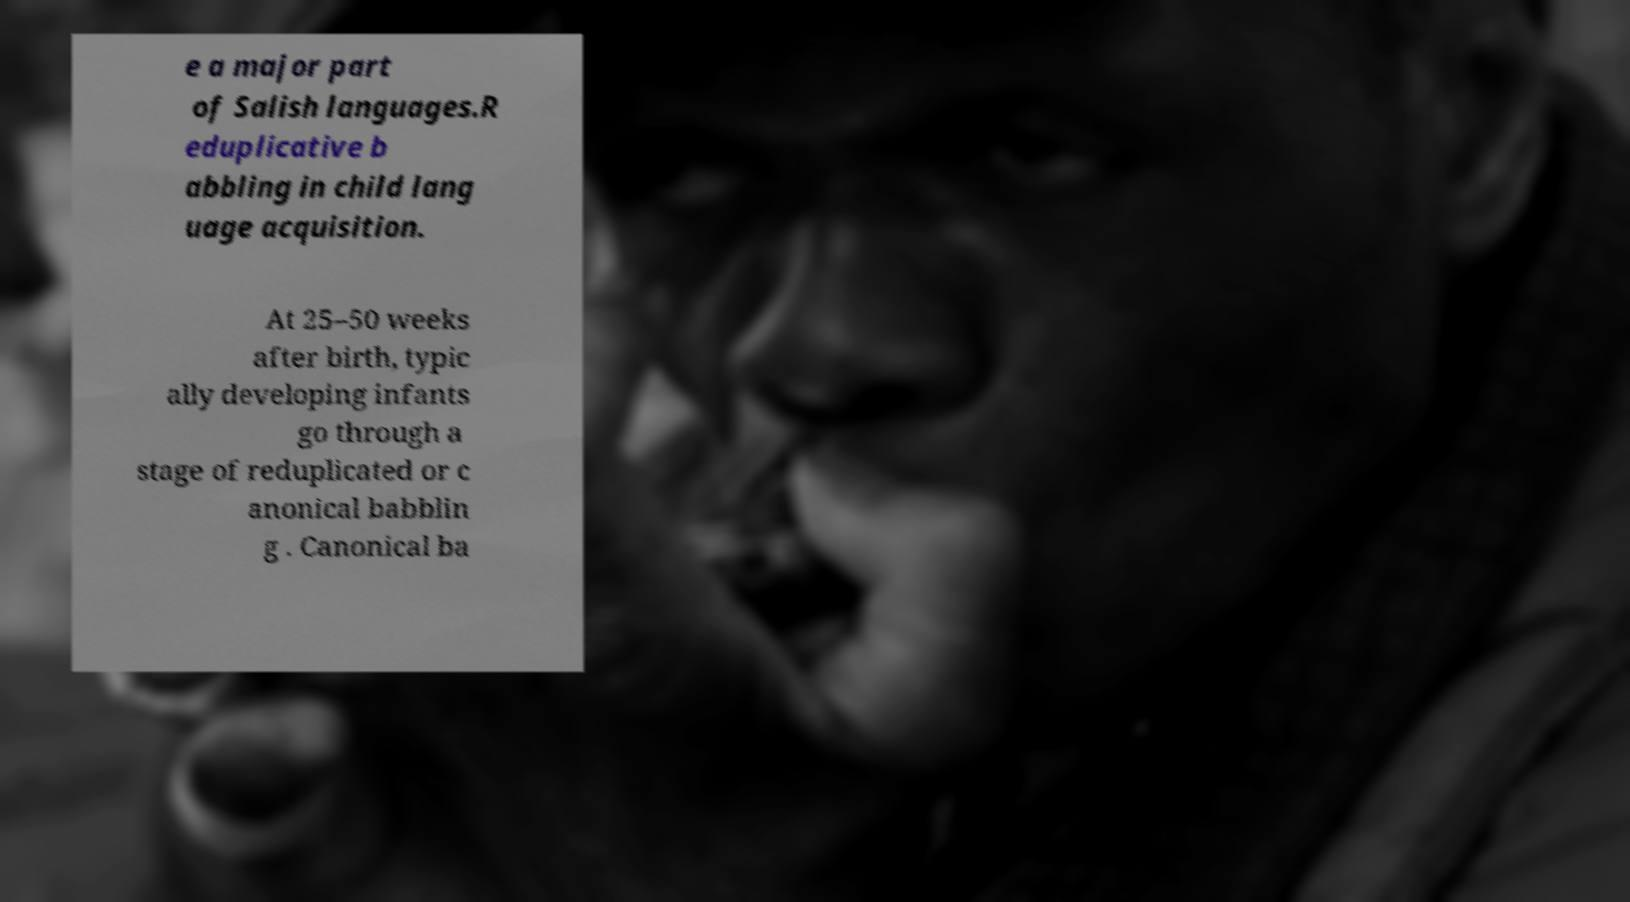Can you read and provide the text displayed in the image?This photo seems to have some interesting text. Can you extract and type it out for me? e a major part of Salish languages.R eduplicative b abbling in child lang uage acquisition. At 25–50 weeks after birth, typic ally developing infants go through a stage of reduplicated or c anonical babblin g . Canonical ba 